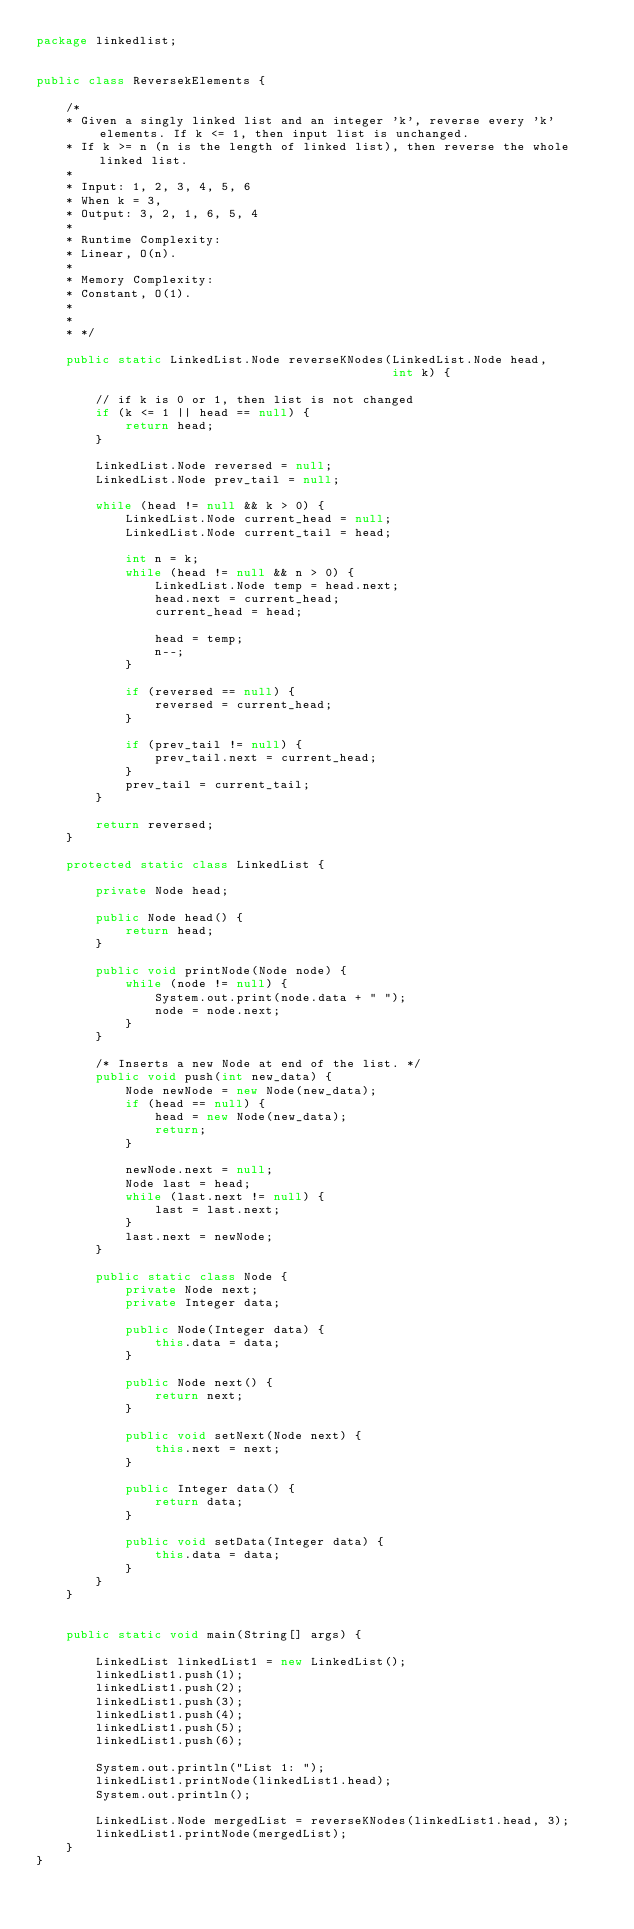Convert code to text. <code><loc_0><loc_0><loc_500><loc_500><_Java_>package linkedlist;


public class ReversekElements {

    /*
    * Given a singly linked list and an integer 'k', reverse every 'k' elements. If k <= 1, then input list is unchanged.
    * If k >= n (n is the length of linked list), then reverse the whole linked list.
    *
    * Input: 1, 2, 3, 4, 5, 6
    * When k = 3,
    * Output: 3, 2, 1, 6, 5, 4
    *
    * Runtime Complexity:
    * Linear, O(n).
    *
    * Memory Complexity:
    * Constant, O(1).
    *
    *
    * */

    public static LinkedList.Node reverseKNodes(LinkedList.Node head,
                                                int k) {

        // if k is 0 or 1, then list is not changed
        if (k <= 1 || head == null) {
            return head;
        }

        LinkedList.Node reversed = null;
        LinkedList.Node prev_tail = null;

        while (head != null && k > 0) {
            LinkedList.Node current_head = null;
            LinkedList.Node current_tail = head;

            int n = k;
            while (head != null && n > 0) {
                LinkedList.Node temp = head.next;
                head.next = current_head;
                current_head = head;

                head = temp;
                n--;
            }

            if (reversed == null) {
                reversed = current_head;
            }

            if (prev_tail != null) {
                prev_tail.next = current_head;
            }
            prev_tail = current_tail;
        }

        return reversed;
    }

    protected static class LinkedList {

        private Node head;

        public Node head() {
            return head;
        }

        public void printNode(Node node) {
            while (node != null) {
                System.out.print(node.data + " ");
                node = node.next;
            }
        }

        /* Inserts a new Node at end of the list. */
        public void push(int new_data) {
            Node newNode = new Node(new_data);
            if (head == null) {
                head = new Node(new_data);
                return;
            }

            newNode.next = null;
            Node last = head;
            while (last.next != null) {
                last = last.next;
            }
            last.next = newNode;
        }

        public static class Node {
            private Node next;
            private Integer data;

            public Node(Integer data) {
                this.data = data;
            }

            public Node next() {
                return next;
            }

            public void setNext(Node next) {
                this.next = next;
            }

            public Integer data() {
                return data;
            }

            public void setData(Integer data) {
                this.data = data;
            }
        }
    }


    public static void main(String[] args) {

        LinkedList linkedList1 = new LinkedList();
        linkedList1.push(1);
        linkedList1.push(2);
        linkedList1.push(3);
        linkedList1.push(4);
        linkedList1.push(5);
        linkedList1.push(6);

        System.out.println("List 1: ");
        linkedList1.printNode(linkedList1.head);
        System.out.println();

        LinkedList.Node mergedList = reverseKNodes(linkedList1.head, 3);
        linkedList1.printNode(mergedList);
    }
}
</code> 